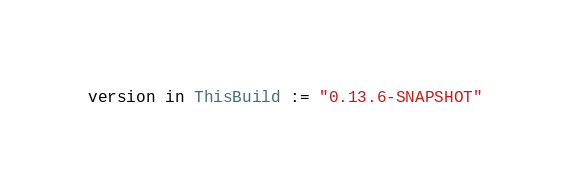<code> <loc_0><loc_0><loc_500><loc_500><_Scala_>version in ThisBuild := "0.13.6-SNAPSHOT"
</code> 